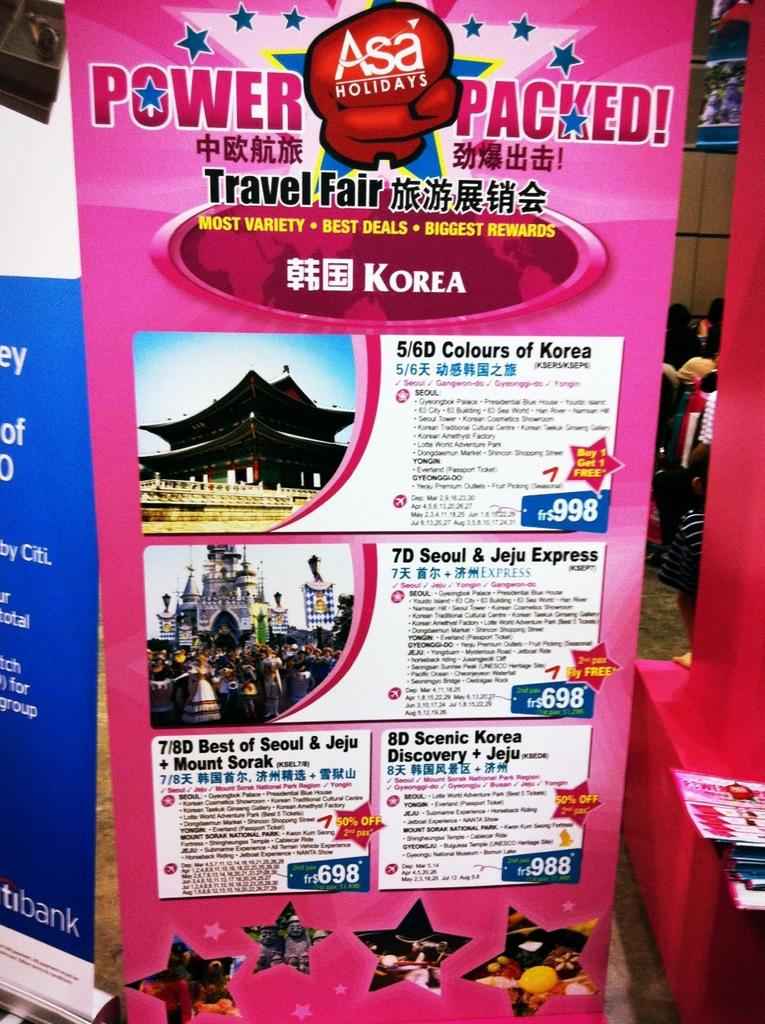<image>
Write a terse but informative summary of the picture. a pink sign with Asa Holidays written on it 